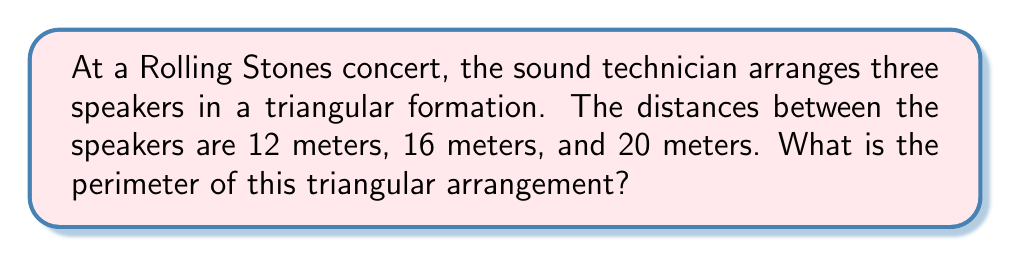Give your solution to this math problem. Let's approach this step-by-step:

1) The perimeter of a triangle is the sum of the lengths of all its sides.

2) In this case, we're given the lengths of all three sides:
   - Side 1: 12 meters
   - Side 2: 16 meters
   - Side 3: 20 meters

3) To find the perimeter, we simply add these lengths:

   $$\text{Perimeter} = 12 + 16 + 20$$

4) Calculating:

   $$\text{Perimeter} = 48 \text{ meters}$$

5) Therefore, the perimeter of the triangular arrangement of speakers is 48 meters.

Note: This triangle satisfies the triangle inequality theorem, which states that the sum of the lengths of any two sides of a triangle must be greater than the length of the remaining side. We can verify this:
   12 + 16 > 20
   12 + 20 > 16
   16 + 20 > 12
All these inequalities hold true, confirming that this is indeed a valid triangle.
Answer: 48 meters 